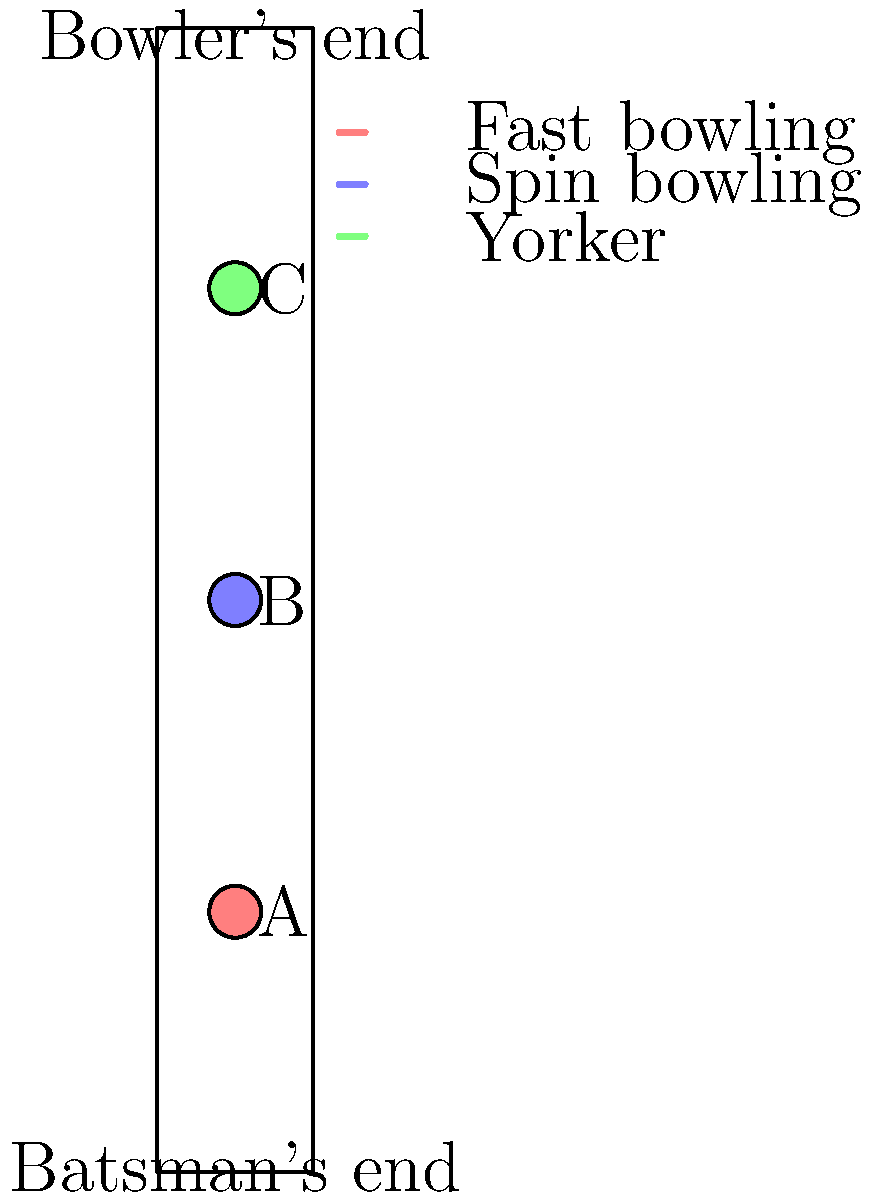Analyze the impact zones A, B, and C on the cricket pitch diagram. Which bowling technique is most likely to produce the impact zone B, and how does this affect the batsman's strategy? To answer this question, we need to analyze the impact zones and their positions on the cricket pitch:

1. Zone A (red): Located close to the batsman's end. This is typical for fast bowling, which tends to bounce closer to the batsman.

2. Zone B (blue): Located in the middle of the pitch. This is characteristic of spin bowling, which often lands in the middle of the pitch and then deviates after bouncing.

3. Zone C (green): Located closer to the bowler's end. This represents a yorker, a full-length delivery aimed at the batsman's feet.

Given that Zone B is in the middle of the pitch, it is most likely produced by spin bowling. This affects the batsman's strategy in several ways:

1. Increased reaction time: The ball has more time to travel, giving the batsman slightly more time to read the delivery.

2. Spin deviation: After bouncing, the ball can turn significantly, making it challenging to predict its path.

3. Varied bounce: Depending on the type of spin (off-spin or leg-spin), the ball may bounce at different heights and angles.

4. Shot selection: The batsman might need to play more defensive shots or use their feet to counter the spin.

5. Mental preparation: The batsman must be prepared for both the initial trajectory and the post-bounce movement.

Understanding these factors, a batsman would likely adopt a strategy that involves:
- Watching the ball closely from the bowler's hand
- Being prepared to adjust their shot based on the post-bounce movement
- Potentially using their feet to get to the pitch of the ball
- Employing sweep shots or other techniques to counter the spin
Answer: Spin bowling; requires careful reading of spin and bounce, defensive play, and foot movement from the batsman. 